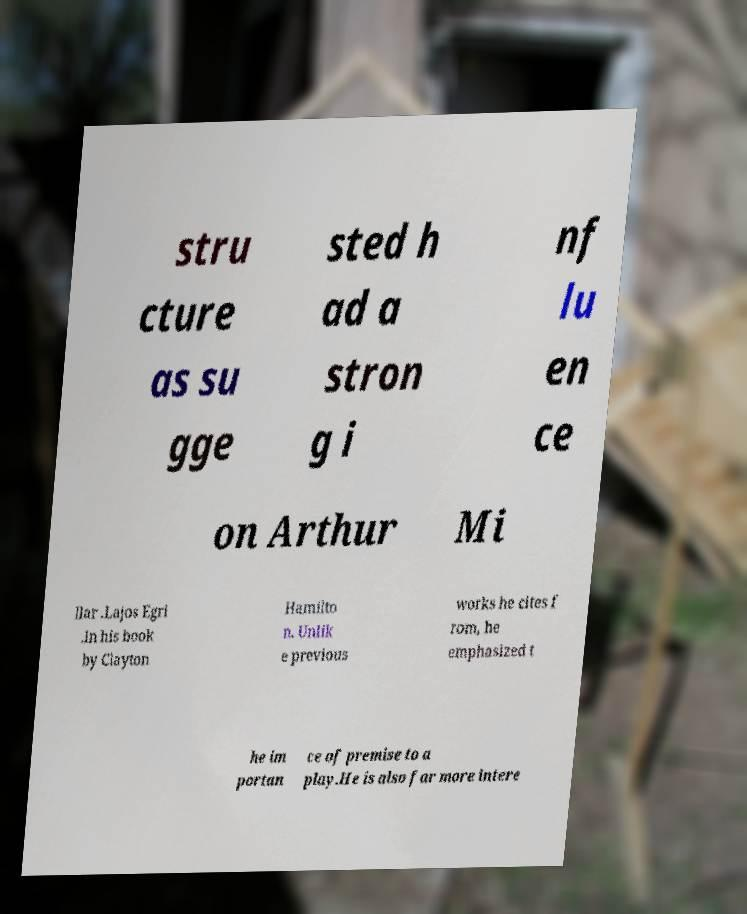Can you accurately transcribe the text from the provided image for me? stru cture as su gge sted h ad a stron g i nf lu en ce on Arthur Mi llar .Lajos Egri .In his book by Clayton Hamilto n. Unlik e previous works he cites f rom, he emphasized t he im portan ce of premise to a play.He is also far more intere 